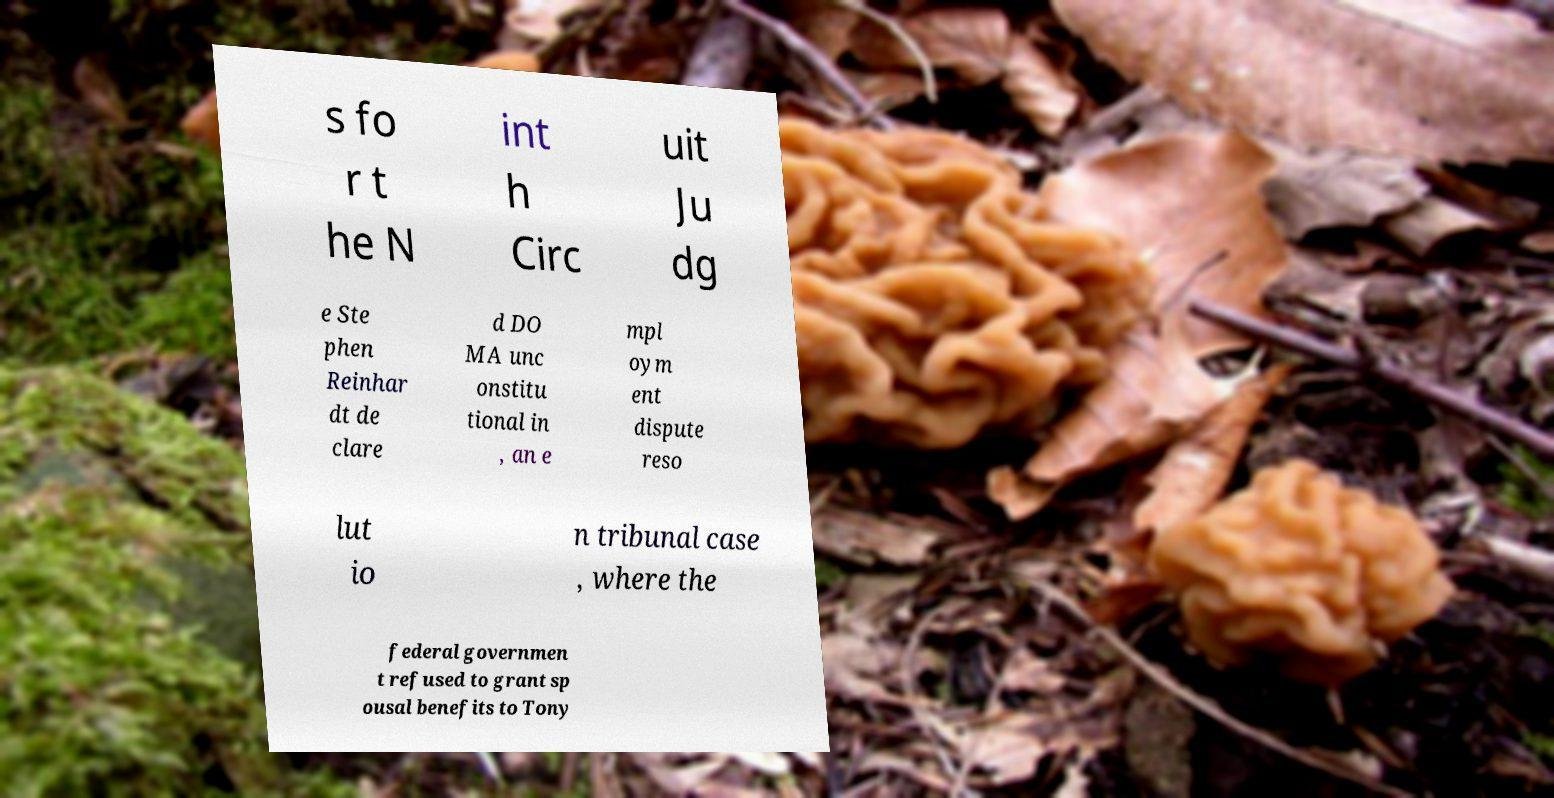Can you accurately transcribe the text from the provided image for me? s fo r t he N int h Circ uit Ju dg e Ste phen Reinhar dt de clare d DO MA unc onstitu tional in , an e mpl oym ent dispute reso lut io n tribunal case , where the federal governmen t refused to grant sp ousal benefits to Tony 